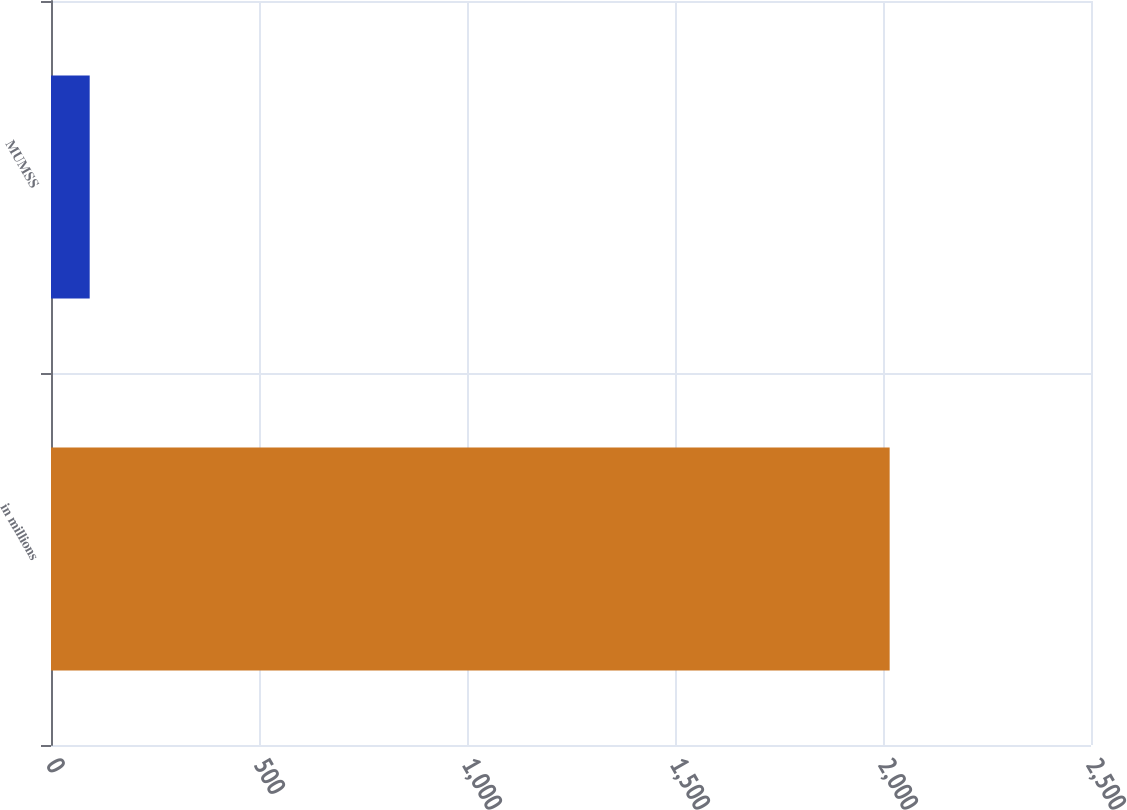Convert chart to OTSL. <chart><loc_0><loc_0><loc_500><loc_500><bar_chart><fcel>in millions<fcel>MUMSS<nl><fcel>2016<fcel>93<nl></chart> 